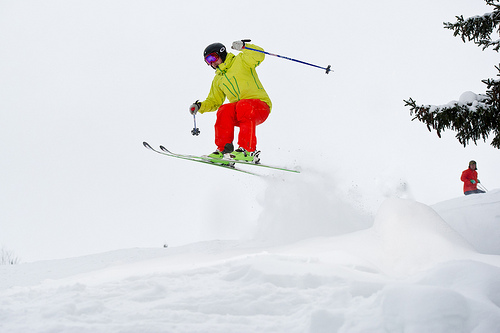What can you tell me about the weather conditions? The sky is overcast, and the white blanket of snow suggests recent snowfall, ideal conditions for skiing with ample powder on the slopes. 